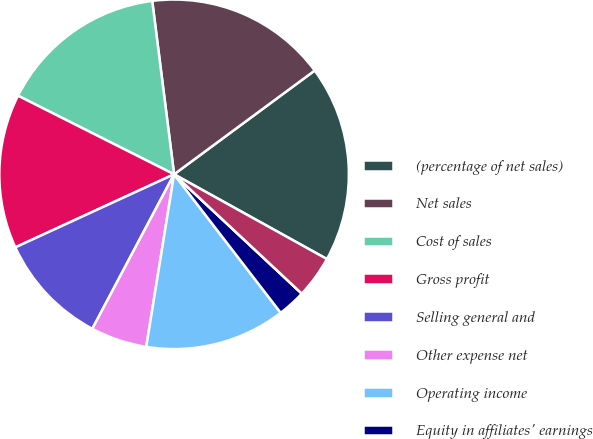<chart> <loc_0><loc_0><loc_500><loc_500><pie_chart><fcel>(percentage of net sales)<fcel>Net sales<fcel>Cost of sales<fcel>Gross profit<fcel>Selling general and<fcel>Other expense net<fcel>Operating income<fcel>Equity in affiliates' earnings<fcel>Interest income<fcel>Interest expense and finance<nl><fcel>18.18%<fcel>16.88%<fcel>15.58%<fcel>14.29%<fcel>10.39%<fcel>5.2%<fcel>12.99%<fcel>2.6%<fcel>0.0%<fcel>3.9%<nl></chart> 